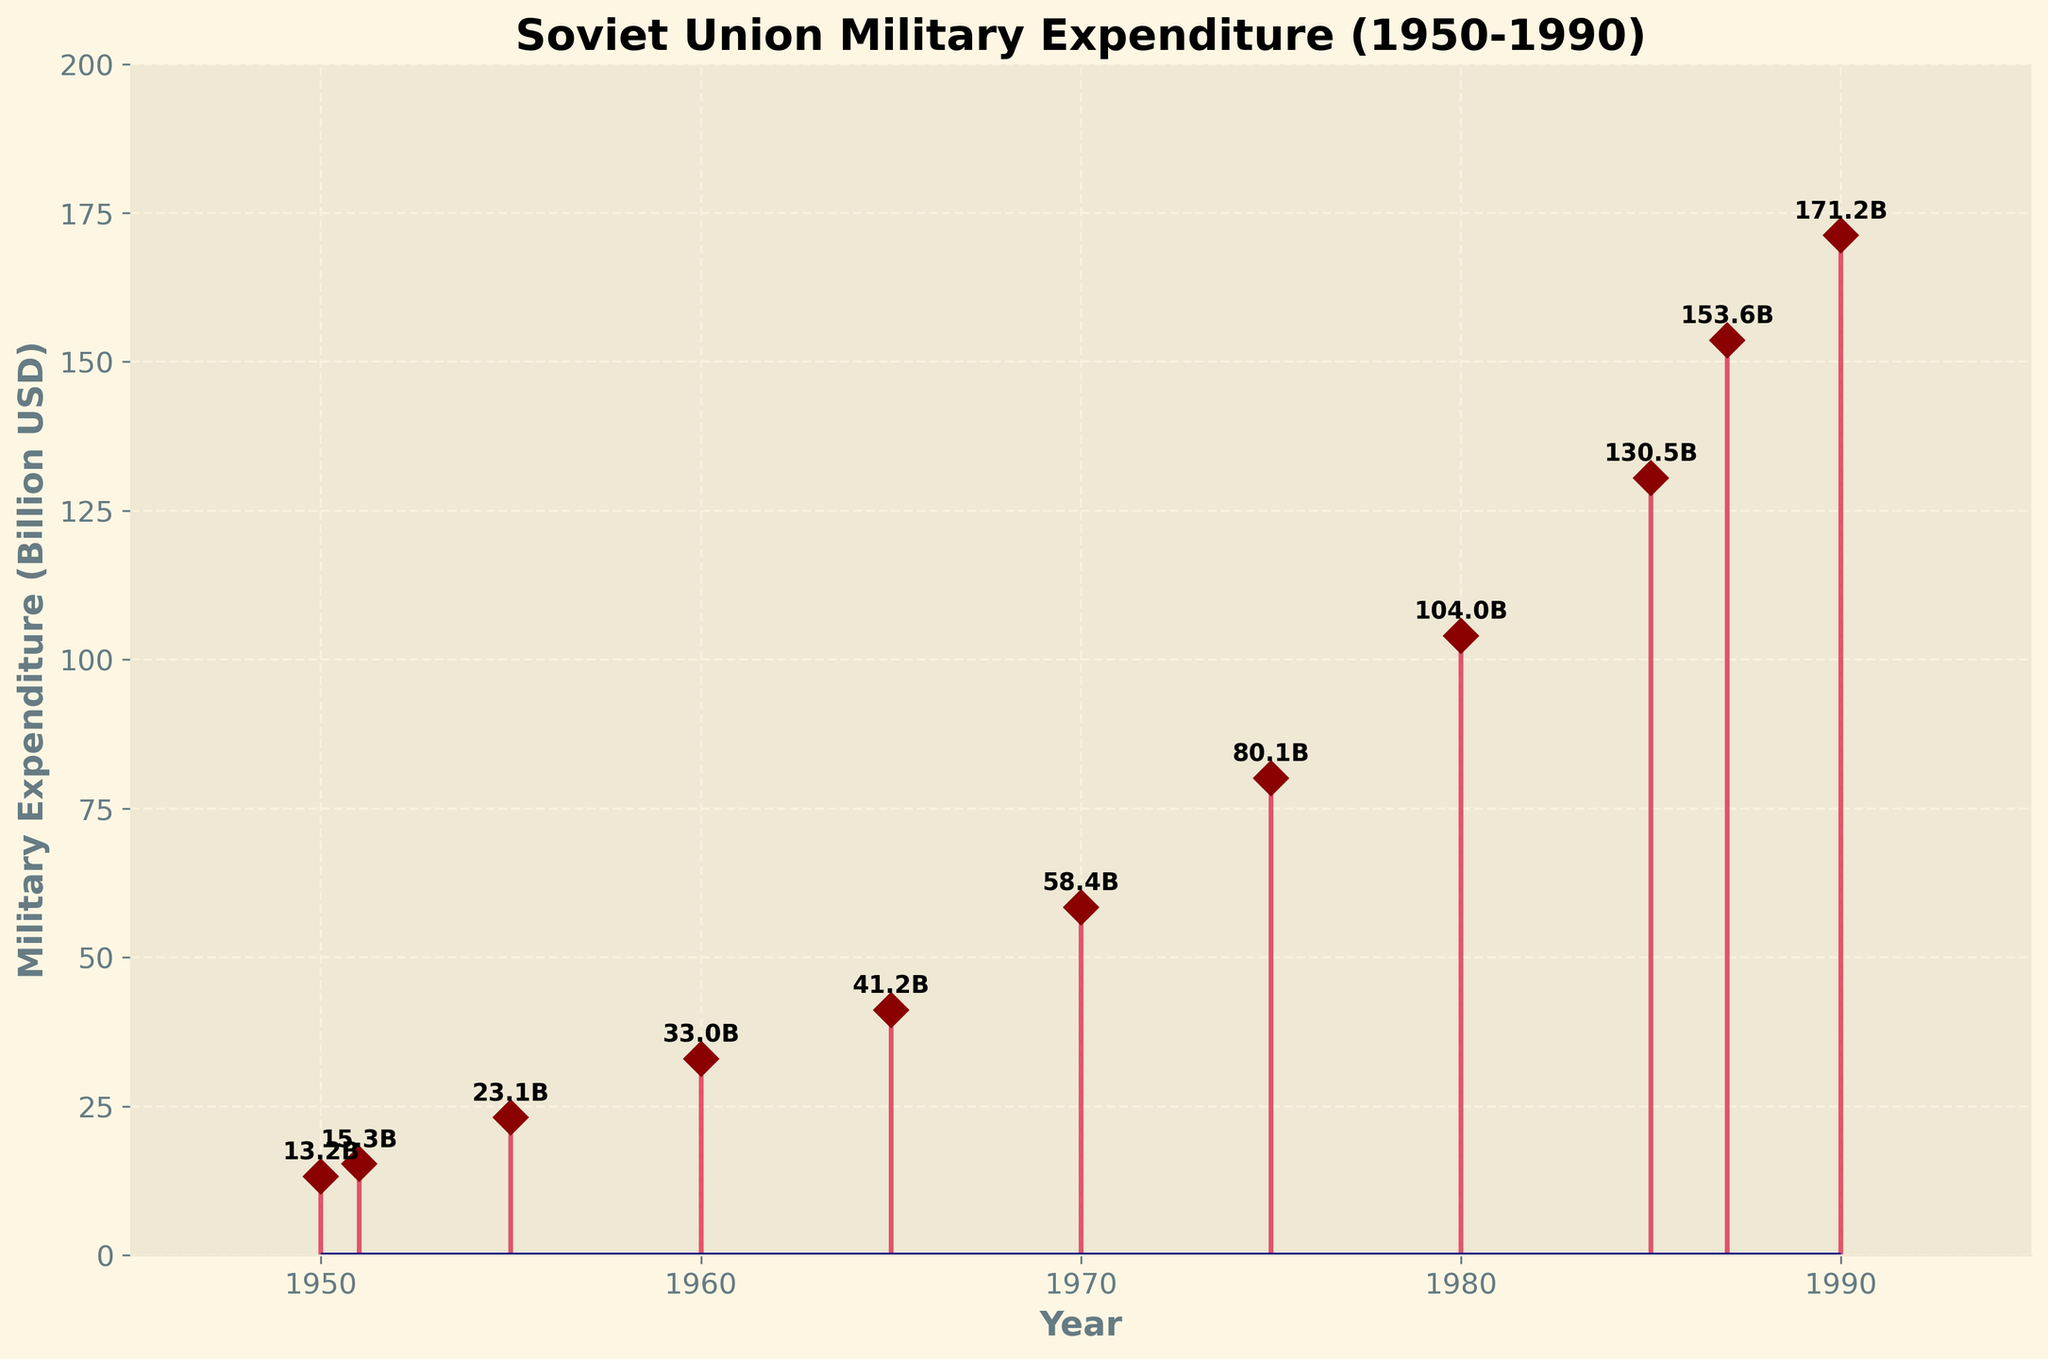What is the title of the figure? The title of the figure is typically displayed at the top of the plot.
Answer: Soviet Union Military Expenditure (1950-1990) How many data points are there in total in the figure? The data points are visually represented by the markers on the stem plot. By counting these markers, we can determine the total number. We can count 11 such markers.
Answer: 11 What is the highest military expenditure value shown in the figure? The highest military expenditure value can be identified by looking at the tallest stem in the plot. The label on the highest stem shows 171.2 billion USD in 1990.
Answer: 171.2 billion USD During which year did the Soviet Union's military expenditure first exceed 100 billion USD? By identifying the year linked to the stem where the expenditure first surpasses 100 billion USD, we see it occurs in the year 1980.
Answer: 1980 What is the difference in military expenditure between 1970 and 1985? Identify the expenditure in 1970 (58.4 billion USD) and 1985 (130.5 billion USD). Calculate the difference: 130.5 - 58.4 = 72.1 billion USD.
Answer: 72.1 billion USD Which decade showed the greatest increase in military expenditure from its beginning to its end as represented in this plot? Compare expenditure increase across 1950s (13.2 to 23.1 from 1950 to 1955), 1960s (33.0 to 41.2 from 1960 to 1965), 1970s (58.4 to 80.1 from 1970 to 1975), and 1980s to 1990s (104.0 to 171.2). The greatest increase, 67.2 billion USD, is from the 1980s to 1990s.
Answer: 1980s to 1990s Which year experienced a higher military expenditure, 1965 or 1975? Compare the military expenditures in 1965 (41.2 billion USD) and 1975 (80.1 billion USD). 1975 shows a higher expenditure.
Answer: 1975 How much did the military expenditure increase between 1960 and 1965? Identify the expenditures in 1960 (33 billion USD) and 1965 (41.2 billion USD). Then calculate the difference: 41.2 - 33 = 8.2 billion USD.
Answer: 8.2 billion USD What is the average military expenditure over the five periods listed in the 1980s and 1990s? Collect the expenditure values for the periods listed (104.0, 130.5, 153.6, 171.2). Add them (104.0 + 130.5 + 153.6 + 171.2) and divide by the number of periods (4). The average is (559.3 / 4) = 139.825 billion USD.
Answer: 139.825 billion USD What is the color of the line that represents the data points in the stem plot? The color of the line can be identified by visually inspecting the plot. It's shown in crimson with dark red markers.
Answer: Crimson 